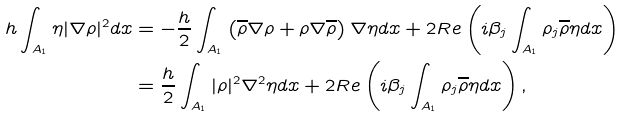<formula> <loc_0><loc_0><loc_500><loc_500>h \int _ { A _ { 1 } } \eta | \nabla \rho | ^ { 2 } d x & = - \frac { h } { 2 } \int _ { A _ { 1 } } \left ( \overline { \rho } \nabla \rho + \rho \nabla \overline { \rho } \right ) \nabla \eta d x + 2 R e \left ( i \beta _ { j } \int _ { A _ { 1 } } \rho _ { j } \overline { \rho } \eta d x \right ) \\ & = \frac { h } { 2 } \int _ { A _ { 1 } } | \rho | ^ { 2 } \nabla ^ { 2 } \eta d x + 2 R e \left ( i \beta _ { j } \int _ { A _ { 1 } } \rho _ { j } \overline { \rho } \eta d x \right ) ,</formula> 